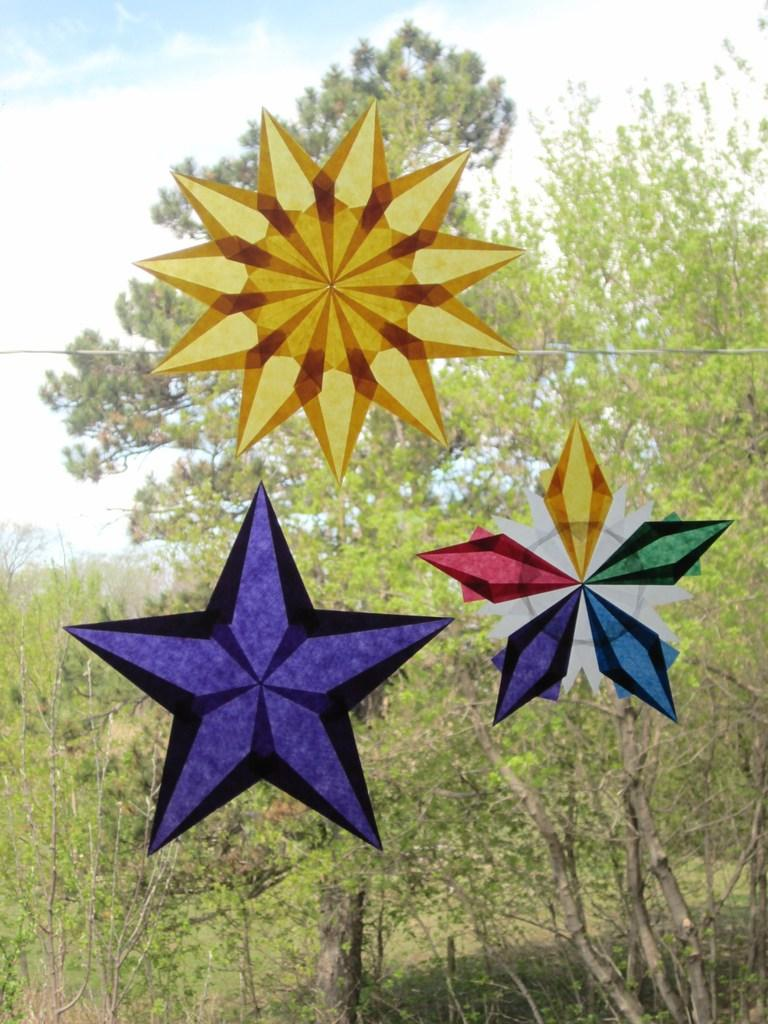What is on the glass in the image? There are three stickers on the glass. Can you describe the appearance of the stickers? The stickers are colorful. What can be seen in the background of the image? There are many trees and clouds in the background of the image. What part of the natural environment is visible in the image? The sky is visible in the background of the image. What type of land can be seen in the image? There is no specific land visible in the image; it primarily features trees, clouds, and the sky in the background. How do the stickers express their feelings of hate in the image? The stickers do not express any feelings, as they are inanimate objects and do not have emotions. 